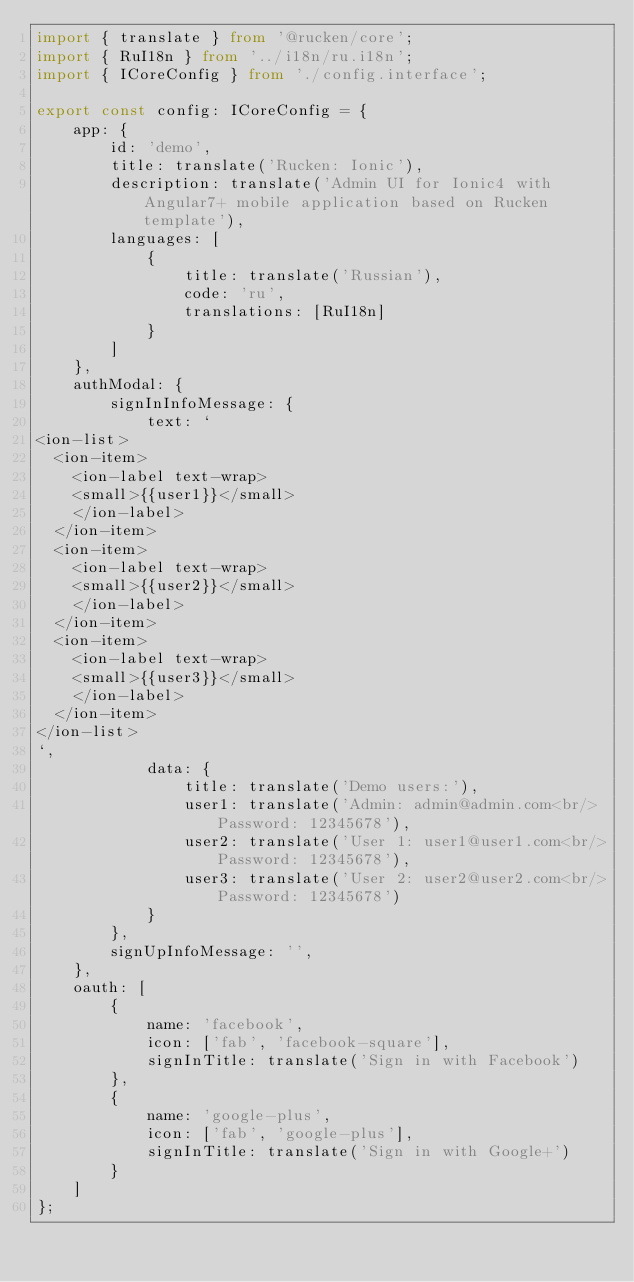Convert code to text. <code><loc_0><loc_0><loc_500><loc_500><_TypeScript_>import { translate } from '@rucken/core';
import { RuI18n } from '../i18n/ru.i18n';
import { ICoreConfig } from './config.interface';

export const config: ICoreConfig = {
    app: {
        id: 'demo',
        title: translate('Rucken: Ionic'),
        description: translate('Admin UI for Ionic4 with Angular7+ mobile application based on Rucken template'),
        languages: [
            {
                title: translate('Russian'),
                code: 'ru',
                translations: [RuI18n]
            }
        ]
    },
    authModal: {
        signInInfoMessage: {
            text: `
<ion-list>
  <ion-item>
    <ion-label text-wrap>
    <small>{{user1}}</small>
    </ion-label>
  </ion-item>
  <ion-item>
    <ion-label text-wrap>
    <small>{{user2}}</small>
    </ion-label>
  </ion-item>
  <ion-item>
    <ion-label text-wrap>
    <small>{{user3}}</small>
    </ion-label>
  </ion-item>
</ion-list>
`,
            data: {
                title: translate('Demo users:'),
                user1: translate('Admin: admin@admin.com<br/>Password: 12345678'),
                user2: translate('User 1: user1@user1.com<br/>Password: 12345678'),
                user3: translate('User 2: user2@user2.com<br/>Password: 12345678')
            }
        },
        signUpInfoMessage: '',
    },
    oauth: [
        {
            name: 'facebook',
            icon: ['fab', 'facebook-square'],
            signInTitle: translate('Sign in with Facebook')
        },
        {
            name: 'google-plus',
            icon: ['fab', 'google-plus'],
            signInTitle: translate('Sign in with Google+')
        }
    ]
};
</code> 